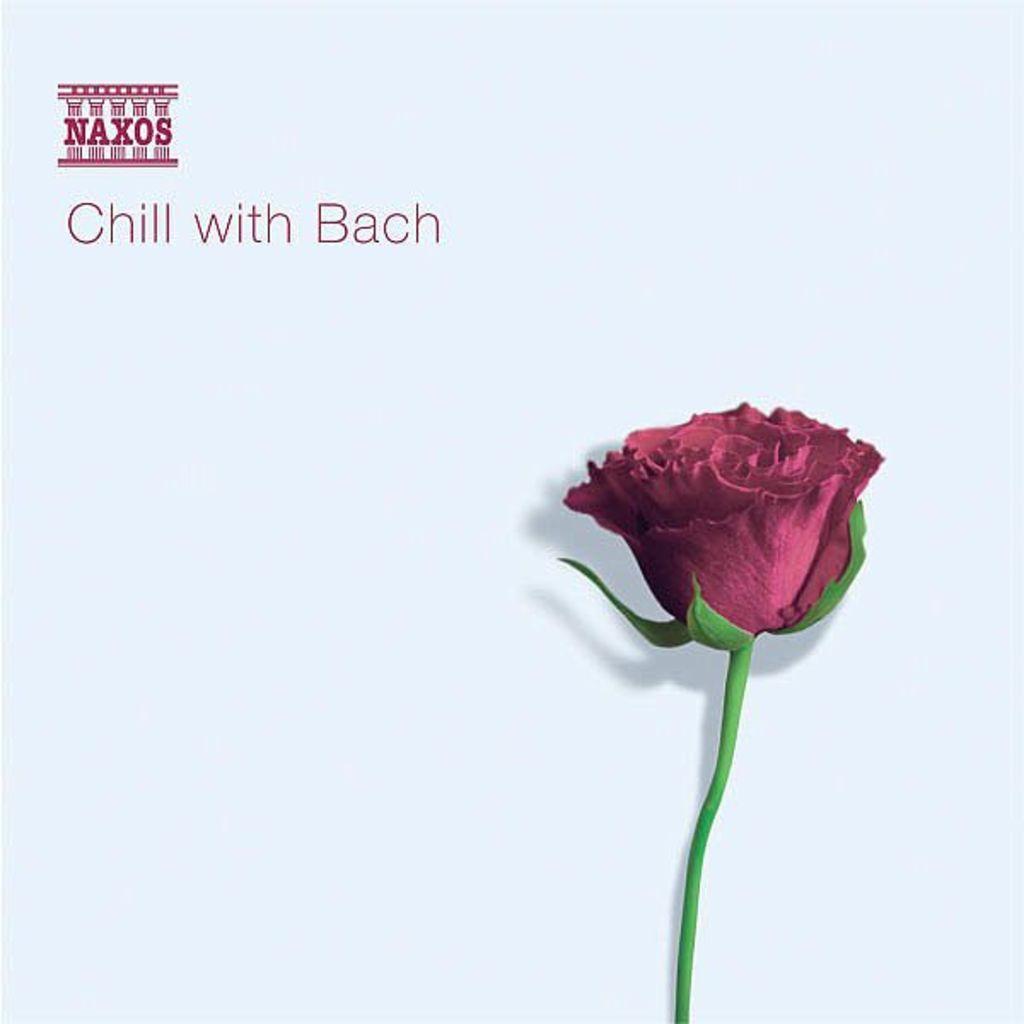Please provide a concise description of this image. In this image I can see the rose which is in red and green color. To the left I can see the text chill with Bach is written on the white color surface. 